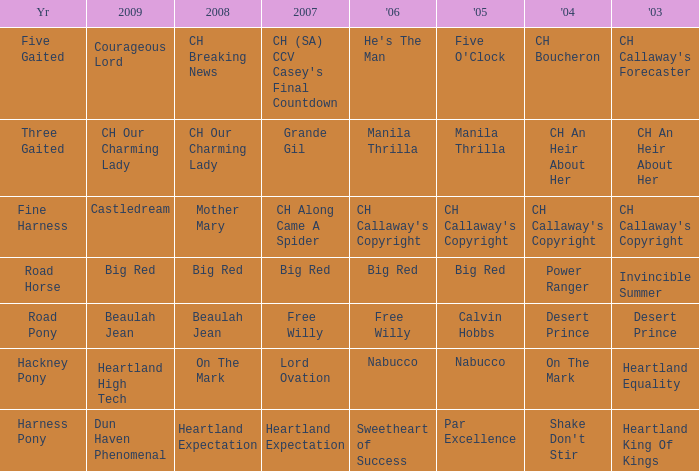Can you give me this table as a dict? {'header': ['Yr', '2009', '2008', '2007', "'06", "'05", "'04", "'03"], 'rows': [['Five Gaited', 'Courageous Lord', 'CH Breaking News', "CH (SA) CCV Casey's Final Countdown", "He's The Man", "Five O'Clock", 'CH Boucheron', "CH Callaway's Forecaster"], ['Three Gaited', 'CH Our Charming Lady', 'CH Our Charming Lady', 'Grande Gil', 'Manila Thrilla', 'Manila Thrilla', 'CH An Heir About Her', 'CH An Heir About Her'], ['Fine Harness', 'Castledream', 'Mother Mary', 'CH Along Came A Spider', "CH Callaway's Copyright", "CH Callaway's Copyright", "CH Callaway's Copyright", "CH Callaway's Copyright"], ['Road Horse', 'Big Red', 'Big Red', 'Big Red', 'Big Red', 'Big Red', 'Power Ranger', 'Invincible Summer'], ['Road Pony', 'Beaulah Jean', 'Beaulah Jean', 'Free Willy', 'Free Willy', 'Calvin Hobbs', 'Desert Prince', 'Desert Prince'], ['Hackney Pony', 'Heartland High Tech', 'On The Mark', 'Lord Ovation', 'Nabucco', 'Nabucco', 'On The Mark', 'Heartland Equality'], ['Harness Pony', 'Dun Haven Phenomenal', 'Heartland Expectation', 'Heartland Expectation', 'Sweetheart of Success', 'Par Excellence', "Shake Don't Stir", 'Heartland King Of Kings']]} What is the 2008 for 2009 heartland high tech? On The Mark. 